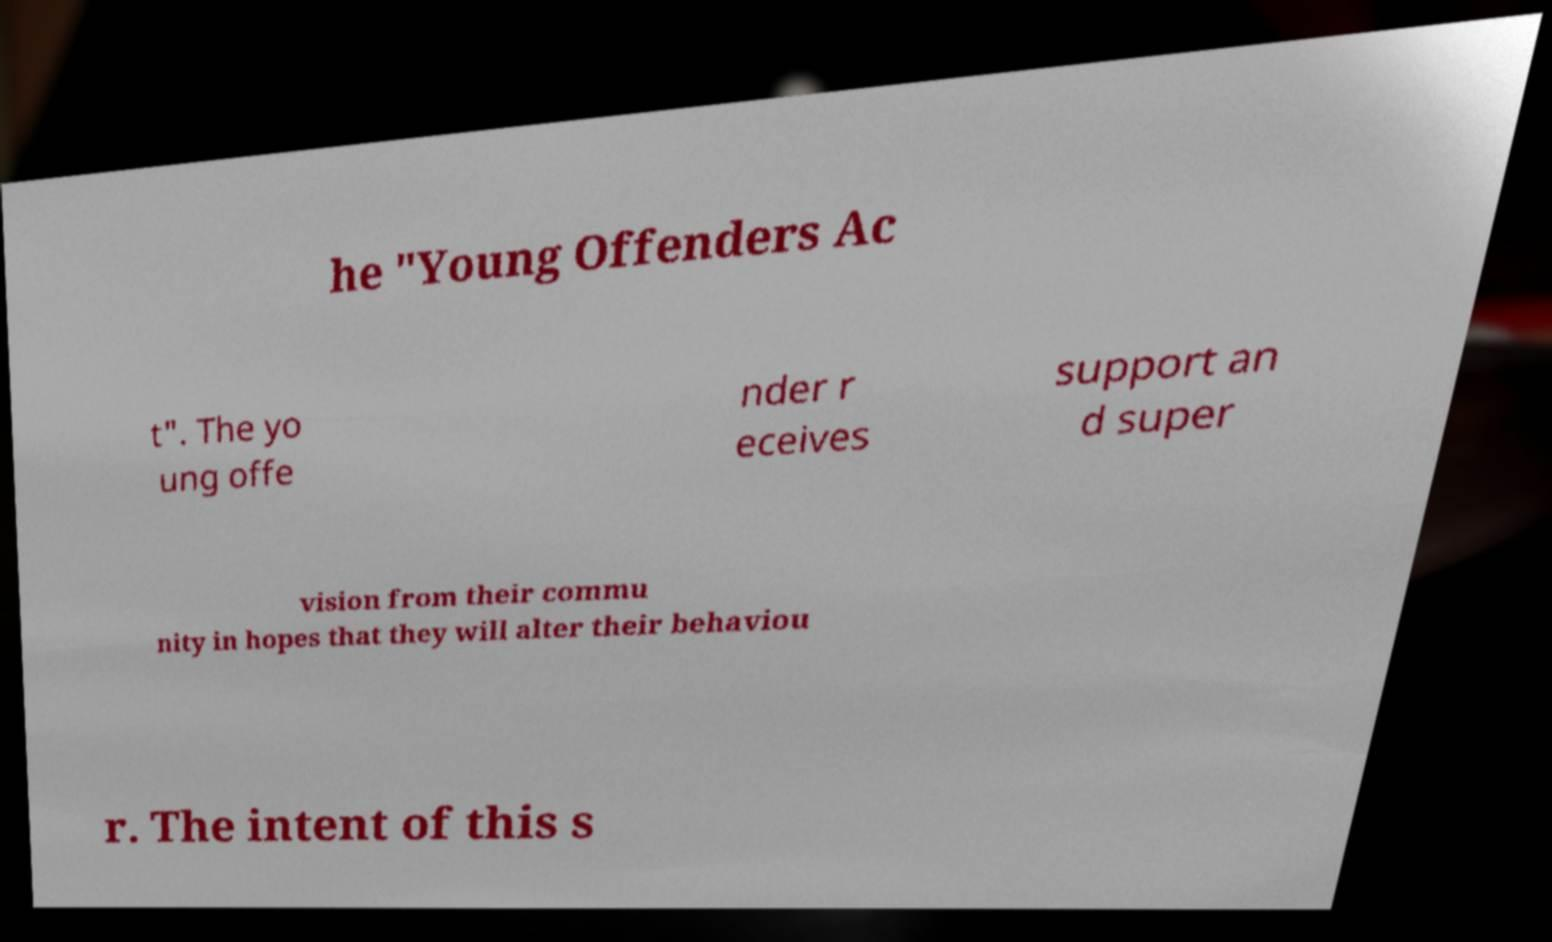What messages or text are displayed in this image? I need them in a readable, typed format. he "Young Offenders Ac t". The yo ung offe nder r eceives support an d super vision from their commu nity in hopes that they will alter their behaviou r. The intent of this s 